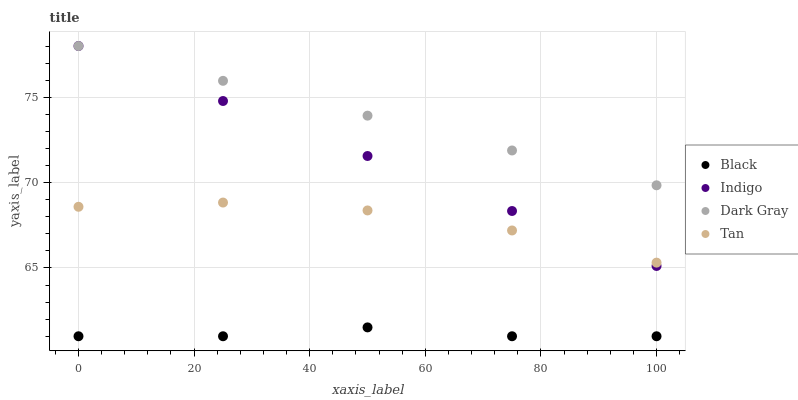Does Black have the minimum area under the curve?
Answer yes or no. Yes. Does Dark Gray have the maximum area under the curve?
Answer yes or no. Yes. Does Indigo have the minimum area under the curve?
Answer yes or no. No. Does Indigo have the maximum area under the curve?
Answer yes or no. No. Is Dark Gray the smoothest?
Answer yes or no. Yes. Is Tan the roughest?
Answer yes or no. Yes. Is Indigo the smoothest?
Answer yes or no. No. Is Indigo the roughest?
Answer yes or no. No. Does Black have the lowest value?
Answer yes or no. Yes. Does Indigo have the lowest value?
Answer yes or no. No. Does Indigo have the highest value?
Answer yes or no. Yes. Does Tan have the highest value?
Answer yes or no. No. Is Black less than Indigo?
Answer yes or no. Yes. Is Tan greater than Black?
Answer yes or no. Yes. Does Indigo intersect Tan?
Answer yes or no. Yes. Is Indigo less than Tan?
Answer yes or no. No. Is Indigo greater than Tan?
Answer yes or no. No. Does Black intersect Indigo?
Answer yes or no. No. 